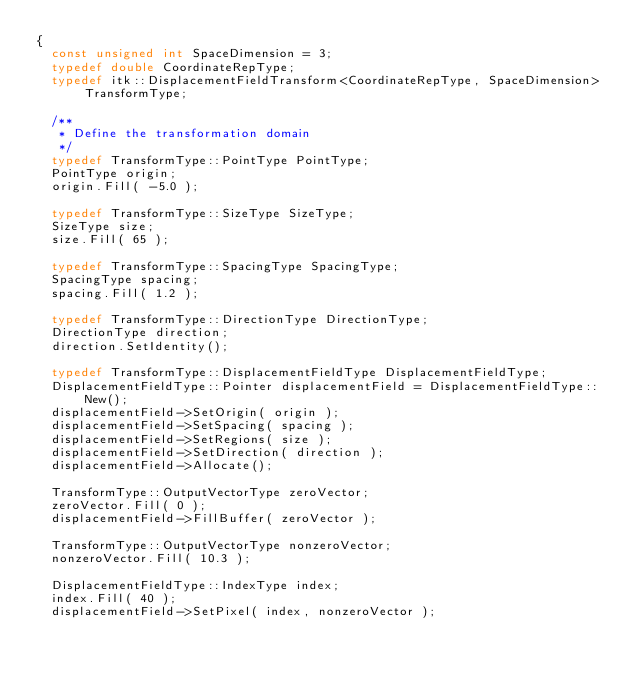<code> <loc_0><loc_0><loc_500><loc_500><_C++_>{
  const unsigned int SpaceDimension = 3;
  typedef double CoordinateRepType;
  typedef itk::DisplacementFieldTransform<CoordinateRepType, SpaceDimension> TransformType;

  /**
   * Define the transformation domain
   */
  typedef TransformType::PointType PointType;
  PointType origin;
  origin.Fill( -5.0 );

  typedef TransformType::SizeType SizeType;
  SizeType size;
  size.Fill( 65 );

  typedef TransformType::SpacingType SpacingType;
  SpacingType spacing;
  spacing.Fill( 1.2 );

  typedef TransformType::DirectionType DirectionType;
  DirectionType direction;
  direction.SetIdentity();

  typedef TransformType::DisplacementFieldType DisplacementFieldType;
  DisplacementFieldType::Pointer displacementField = DisplacementFieldType::New();
  displacementField->SetOrigin( origin );
  displacementField->SetSpacing( spacing );
  displacementField->SetRegions( size );
  displacementField->SetDirection( direction );
  displacementField->Allocate();

  TransformType::OutputVectorType zeroVector;
  zeroVector.Fill( 0 );
  displacementField->FillBuffer( zeroVector );

  TransformType::OutputVectorType nonzeroVector;
  nonzeroVector.Fill( 10.3 );

  DisplacementFieldType::IndexType index;
  index.Fill( 40 );
  displacementField->SetPixel( index, nonzeroVector );
</code> 